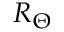<formula> <loc_0><loc_0><loc_500><loc_500>R _ { \Theta }</formula> 